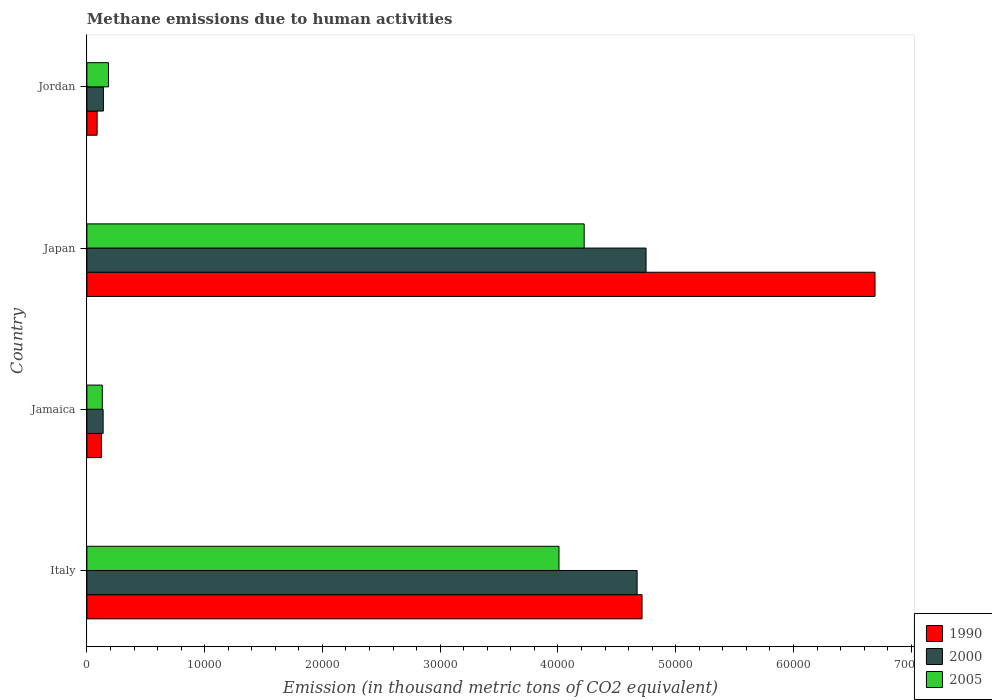How many different coloured bars are there?
Make the answer very short. 3. Are the number of bars on each tick of the Y-axis equal?
Ensure brevity in your answer.  Yes. How many bars are there on the 2nd tick from the top?
Your answer should be compact. 3. How many bars are there on the 4th tick from the bottom?
Your answer should be compact. 3. What is the label of the 1st group of bars from the top?
Offer a very short reply. Jordan. What is the amount of methane emitted in 2005 in Japan?
Your response must be concise. 4.22e+04. Across all countries, what is the maximum amount of methane emitted in 2000?
Keep it short and to the point. 4.75e+04. Across all countries, what is the minimum amount of methane emitted in 2000?
Ensure brevity in your answer.  1379.2. In which country was the amount of methane emitted in 2000 maximum?
Offer a very short reply. Japan. In which country was the amount of methane emitted in 2005 minimum?
Make the answer very short. Jamaica. What is the total amount of methane emitted in 2000 in the graph?
Give a very brief answer. 9.70e+04. What is the difference between the amount of methane emitted in 2005 in Japan and that in Jordan?
Give a very brief answer. 4.04e+04. What is the difference between the amount of methane emitted in 2005 in Italy and the amount of methane emitted in 1990 in Jordan?
Ensure brevity in your answer.  3.92e+04. What is the average amount of methane emitted in 1990 per country?
Make the answer very short. 2.90e+04. What is the difference between the amount of methane emitted in 2005 and amount of methane emitted in 1990 in Jamaica?
Your answer should be very brief. 71.4. In how many countries, is the amount of methane emitted in 2005 greater than 68000 thousand metric tons?
Offer a terse response. 0. What is the ratio of the amount of methane emitted in 1990 in Japan to that in Jordan?
Make the answer very short. 77.19. Is the amount of methane emitted in 2000 in Jamaica less than that in Jordan?
Your response must be concise. Yes. What is the difference between the highest and the second highest amount of methane emitted in 2000?
Give a very brief answer. 758.6. What is the difference between the highest and the lowest amount of methane emitted in 1990?
Ensure brevity in your answer.  6.61e+04. Is it the case that in every country, the sum of the amount of methane emitted in 2000 and amount of methane emitted in 2005 is greater than the amount of methane emitted in 1990?
Offer a very short reply. Yes. Are all the bars in the graph horizontal?
Ensure brevity in your answer.  Yes. How many countries are there in the graph?
Keep it short and to the point. 4. What is the difference between two consecutive major ticks on the X-axis?
Your answer should be compact. 10000. Does the graph contain grids?
Provide a short and direct response. No. How many legend labels are there?
Offer a terse response. 3. What is the title of the graph?
Your response must be concise. Methane emissions due to human activities. What is the label or title of the X-axis?
Your response must be concise. Emission (in thousand metric tons of CO2 equivalent). What is the label or title of the Y-axis?
Offer a very short reply. Country. What is the Emission (in thousand metric tons of CO2 equivalent) of 1990 in Italy?
Your answer should be compact. 4.71e+04. What is the Emission (in thousand metric tons of CO2 equivalent) in 2000 in Italy?
Offer a very short reply. 4.67e+04. What is the Emission (in thousand metric tons of CO2 equivalent) of 2005 in Italy?
Keep it short and to the point. 4.01e+04. What is the Emission (in thousand metric tons of CO2 equivalent) of 1990 in Jamaica?
Your answer should be very brief. 1235.1. What is the Emission (in thousand metric tons of CO2 equivalent) of 2000 in Jamaica?
Provide a succinct answer. 1379.2. What is the Emission (in thousand metric tons of CO2 equivalent) in 2005 in Jamaica?
Keep it short and to the point. 1306.5. What is the Emission (in thousand metric tons of CO2 equivalent) in 1990 in Japan?
Your answer should be compact. 6.69e+04. What is the Emission (in thousand metric tons of CO2 equivalent) of 2000 in Japan?
Make the answer very short. 4.75e+04. What is the Emission (in thousand metric tons of CO2 equivalent) in 2005 in Japan?
Make the answer very short. 4.22e+04. What is the Emission (in thousand metric tons of CO2 equivalent) in 1990 in Jordan?
Your answer should be very brief. 867.1. What is the Emission (in thousand metric tons of CO2 equivalent) of 2000 in Jordan?
Make the answer very short. 1401.8. What is the Emission (in thousand metric tons of CO2 equivalent) of 2005 in Jordan?
Your response must be concise. 1833.2. Across all countries, what is the maximum Emission (in thousand metric tons of CO2 equivalent) of 1990?
Provide a succinct answer. 6.69e+04. Across all countries, what is the maximum Emission (in thousand metric tons of CO2 equivalent) of 2000?
Provide a succinct answer. 4.75e+04. Across all countries, what is the maximum Emission (in thousand metric tons of CO2 equivalent) in 2005?
Offer a terse response. 4.22e+04. Across all countries, what is the minimum Emission (in thousand metric tons of CO2 equivalent) of 1990?
Offer a very short reply. 867.1. Across all countries, what is the minimum Emission (in thousand metric tons of CO2 equivalent) in 2000?
Offer a very short reply. 1379.2. Across all countries, what is the minimum Emission (in thousand metric tons of CO2 equivalent) of 2005?
Ensure brevity in your answer.  1306.5. What is the total Emission (in thousand metric tons of CO2 equivalent) of 1990 in the graph?
Your answer should be compact. 1.16e+05. What is the total Emission (in thousand metric tons of CO2 equivalent) in 2000 in the graph?
Provide a short and direct response. 9.70e+04. What is the total Emission (in thousand metric tons of CO2 equivalent) in 2005 in the graph?
Provide a short and direct response. 8.55e+04. What is the difference between the Emission (in thousand metric tons of CO2 equivalent) in 1990 in Italy and that in Jamaica?
Your answer should be compact. 4.59e+04. What is the difference between the Emission (in thousand metric tons of CO2 equivalent) of 2000 in Italy and that in Jamaica?
Provide a succinct answer. 4.53e+04. What is the difference between the Emission (in thousand metric tons of CO2 equivalent) of 2005 in Italy and that in Jamaica?
Give a very brief answer. 3.88e+04. What is the difference between the Emission (in thousand metric tons of CO2 equivalent) of 1990 in Italy and that in Japan?
Provide a succinct answer. -1.98e+04. What is the difference between the Emission (in thousand metric tons of CO2 equivalent) of 2000 in Italy and that in Japan?
Keep it short and to the point. -758.6. What is the difference between the Emission (in thousand metric tons of CO2 equivalent) of 2005 in Italy and that in Japan?
Provide a short and direct response. -2140.2. What is the difference between the Emission (in thousand metric tons of CO2 equivalent) in 1990 in Italy and that in Jordan?
Provide a succinct answer. 4.63e+04. What is the difference between the Emission (in thousand metric tons of CO2 equivalent) in 2000 in Italy and that in Jordan?
Your response must be concise. 4.53e+04. What is the difference between the Emission (in thousand metric tons of CO2 equivalent) of 2005 in Italy and that in Jordan?
Make the answer very short. 3.83e+04. What is the difference between the Emission (in thousand metric tons of CO2 equivalent) in 1990 in Jamaica and that in Japan?
Your answer should be compact. -6.57e+04. What is the difference between the Emission (in thousand metric tons of CO2 equivalent) in 2000 in Jamaica and that in Japan?
Ensure brevity in your answer.  -4.61e+04. What is the difference between the Emission (in thousand metric tons of CO2 equivalent) of 2005 in Jamaica and that in Japan?
Provide a short and direct response. -4.09e+04. What is the difference between the Emission (in thousand metric tons of CO2 equivalent) of 1990 in Jamaica and that in Jordan?
Keep it short and to the point. 368. What is the difference between the Emission (in thousand metric tons of CO2 equivalent) in 2000 in Jamaica and that in Jordan?
Keep it short and to the point. -22.6. What is the difference between the Emission (in thousand metric tons of CO2 equivalent) in 2005 in Jamaica and that in Jordan?
Make the answer very short. -526.7. What is the difference between the Emission (in thousand metric tons of CO2 equivalent) of 1990 in Japan and that in Jordan?
Provide a succinct answer. 6.61e+04. What is the difference between the Emission (in thousand metric tons of CO2 equivalent) of 2000 in Japan and that in Jordan?
Your answer should be very brief. 4.61e+04. What is the difference between the Emission (in thousand metric tons of CO2 equivalent) of 2005 in Japan and that in Jordan?
Ensure brevity in your answer.  4.04e+04. What is the difference between the Emission (in thousand metric tons of CO2 equivalent) in 1990 in Italy and the Emission (in thousand metric tons of CO2 equivalent) in 2000 in Jamaica?
Provide a short and direct response. 4.58e+04. What is the difference between the Emission (in thousand metric tons of CO2 equivalent) in 1990 in Italy and the Emission (in thousand metric tons of CO2 equivalent) in 2005 in Jamaica?
Your response must be concise. 4.58e+04. What is the difference between the Emission (in thousand metric tons of CO2 equivalent) in 2000 in Italy and the Emission (in thousand metric tons of CO2 equivalent) in 2005 in Jamaica?
Keep it short and to the point. 4.54e+04. What is the difference between the Emission (in thousand metric tons of CO2 equivalent) in 1990 in Italy and the Emission (in thousand metric tons of CO2 equivalent) in 2000 in Japan?
Give a very brief answer. -339.7. What is the difference between the Emission (in thousand metric tons of CO2 equivalent) of 1990 in Italy and the Emission (in thousand metric tons of CO2 equivalent) of 2005 in Japan?
Ensure brevity in your answer.  4914.3. What is the difference between the Emission (in thousand metric tons of CO2 equivalent) of 2000 in Italy and the Emission (in thousand metric tons of CO2 equivalent) of 2005 in Japan?
Your answer should be compact. 4495.4. What is the difference between the Emission (in thousand metric tons of CO2 equivalent) in 1990 in Italy and the Emission (in thousand metric tons of CO2 equivalent) in 2000 in Jordan?
Your answer should be very brief. 4.57e+04. What is the difference between the Emission (in thousand metric tons of CO2 equivalent) in 1990 in Italy and the Emission (in thousand metric tons of CO2 equivalent) in 2005 in Jordan?
Offer a very short reply. 4.53e+04. What is the difference between the Emission (in thousand metric tons of CO2 equivalent) of 2000 in Italy and the Emission (in thousand metric tons of CO2 equivalent) of 2005 in Jordan?
Your answer should be compact. 4.49e+04. What is the difference between the Emission (in thousand metric tons of CO2 equivalent) of 1990 in Jamaica and the Emission (in thousand metric tons of CO2 equivalent) of 2000 in Japan?
Your response must be concise. -4.62e+04. What is the difference between the Emission (in thousand metric tons of CO2 equivalent) in 1990 in Jamaica and the Emission (in thousand metric tons of CO2 equivalent) in 2005 in Japan?
Provide a succinct answer. -4.10e+04. What is the difference between the Emission (in thousand metric tons of CO2 equivalent) of 2000 in Jamaica and the Emission (in thousand metric tons of CO2 equivalent) of 2005 in Japan?
Provide a succinct answer. -4.09e+04. What is the difference between the Emission (in thousand metric tons of CO2 equivalent) of 1990 in Jamaica and the Emission (in thousand metric tons of CO2 equivalent) of 2000 in Jordan?
Provide a short and direct response. -166.7. What is the difference between the Emission (in thousand metric tons of CO2 equivalent) in 1990 in Jamaica and the Emission (in thousand metric tons of CO2 equivalent) in 2005 in Jordan?
Provide a succinct answer. -598.1. What is the difference between the Emission (in thousand metric tons of CO2 equivalent) in 2000 in Jamaica and the Emission (in thousand metric tons of CO2 equivalent) in 2005 in Jordan?
Your response must be concise. -454. What is the difference between the Emission (in thousand metric tons of CO2 equivalent) of 1990 in Japan and the Emission (in thousand metric tons of CO2 equivalent) of 2000 in Jordan?
Your answer should be very brief. 6.55e+04. What is the difference between the Emission (in thousand metric tons of CO2 equivalent) of 1990 in Japan and the Emission (in thousand metric tons of CO2 equivalent) of 2005 in Jordan?
Ensure brevity in your answer.  6.51e+04. What is the difference between the Emission (in thousand metric tons of CO2 equivalent) of 2000 in Japan and the Emission (in thousand metric tons of CO2 equivalent) of 2005 in Jordan?
Keep it short and to the point. 4.57e+04. What is the average Emission (in thousand metric tons of CO2 equivalent) in 1990 per country?
Ensure brevity in your answer.  2.90e+04. What is the average Emission (in thousand metric tons of CO2 equivalent) in 2000 per country?
Your answer should be compact. 2.42e+04. What is the average Emission (in thousand metric tons of CO2 equivalent) of 2005 per country?
Your answer should be very brief. 2.14e+04. What is the difference between the Emission (in thousand metric tons of CO2 equivalent) in 1990 and Emission (in thousand metric tons of CO2 equivalent) in 2000 in Italy?
Keep it short and to the point. 418.9. What is the difference between the Emission (in thousand metric tons of CO2 equivalent) of 1990 and Emission (in thousand metric tons of CO2 equivalent) of 2005 in Italy?
Keep it short and to the point. 7054.5. What is the difference between the Emission (in thousand metric tons of CO2 equivalent) in 2000 and Emission (in thousand metric tons of CO2 equivalent) in 2005 in Italy?
Make the answer very short. 6635.6. What is the difference between the Emission (in thousand metric tons of CO2 equivalent) in 1990 and Emission (in thousand metric tons of CO2 equivalent) in 2000 in Jamaica?
Offer a terse response. -144.1. What is the difference between the Emission (in thousand metric tons of CO2 equivalent) in 1990 and Emission (in thousand metric tons of CO2 equivalent) in 2005 in Jamaica?
Provide a succinct answer. -71.4. What is the difference between the Emission (in thousand metric tons of CO2 equivalent) of 2000 and Emission (in thousand metric tons of CO2 equivalent) of 2005 in Jamaica?
Offer a very short reply. 72.7. What is the difference between the Emission (in thousand metric tons of CO2 equivalent) of 1990 and Emission (in thousand metric tons of CO2 equivalent) of 2000 in Japan?
Provide a succinct answer. 1.94e+04. What is the difference between the Emission (in thousand metric tons of CO2 equivalent) of 1990 and Emission (in thousand metric tons of CO2 equivalent) of 2005 in Japan?
Your response must be concise. 2.47e+04. What is the difference between the Emission (in thousand metric tons of CO2 equivalent) of 2000 and Emission (in thousand metric tons of CO2 equivalent) of 2005 in Japan?
Ensure brevity in your answer.  5254. What is the difference between the Emission (in thousand metric tons of CO2 equivalent) of 1990 and Emission (in thousand metric tons of CO2 equivalent) of 2000 in Jordan?
Provide a short and direct response. -534.7. What is the difference between the Emission (in thousand metric tons of CO2 equivalent) of 1990 and Emission (in thousand metric tons of CO2 equivalent) of 2005 in Jordan?
Keep it short and to the point. -966.1. What is the difference between the Emission (in thousand metric tons of CO2 equivalent) of 2000 and Emission (in thousand metric tons of CO2 equivalent) of 2005 in Jordan?
Your answer should be compact. -431.4. What is the ratio of the Emission (in thousand metric tons of CO2 equivalent) in 1990 in Italy to that in Jamaica?
Ensure brevity in your answer.  38.17. What is the ratio of the Emission (in thousand metric tons of CO2 equivalent) of 2000 in Italy to that in Jamaica?
Provide a succinct answer. 33.88. What is the ratio of the Emission (in thousand metric tons of CO2 equivalent) of 2005 in Italy to that in Jamaica?
Offer a terse response. 30.68. What is the ratio of the Emission (in thousand metric tons of CO2 equivalent) in 1990 in Italy to that in Japan?
Your response must be concise. 0.7. What is the ratio of the Emission (in thousand metric tons of CO2 equivalent) of 2005 in Italy to that in Japan?
Offer a very short reply. 0.95. What is the ratio of the Emission (in thousand metric tons of CO2 equivalent) in 1990 in Italy to that in Jordan?
Your answer should be very brief. 54.37. What is the ratio of the Emission (in thousand metric tons of CO2 equivalent) of 2000 in Italy to that in Jordan?
Make the answer very short. 33.33. What is the ratio of the Emission (in thousand metric tons of CO2 equivalent) in 2005 in Italy to that in Jordan?
Your answer should be very brief. 21.87. What is the ratio of the Emission (in thousand metric tons of CO2 equivalent) in 1990 in Jamaica to that in Japan?
Your answer should be very brief. 0.02. What is the ratio of the Emission (in thousand metric tons of CO2 equivalent) of 2000 in Jamaica to that in Japan?
Your response must be concise. 0.03. What is the ratio of the Emission (in thousand metric tons of CO2 equivalent) of 2005 in Jamaica to that in Japan?
Provide a short and direct response. 0.03. What is the ratio of the Emission (in thousand metric tons of CO2 equivalent) of 1990 in Jamaica to that in Jordan?
Provide a short and direct response. 1.42. What is the ratio of the Emission (in thousand metric tons of CO2 equivalent) in 2000 in Jamaica to that in Jordan?
Ensure brevity in your answer.  0.98. What is the ratio of the Emission (in thousand metric tons of CO2 equivalent) in 2005 in Jamaica to that in Jordan?
Your answer should be compact. 0.71. What is the ratio of the Emission (in thousand metric tons of CO2 equivalent) of 1990 in Japan to that in Jordan?
Offer a very short reply. 77.19. What is the ratio of the Emission (in thousand metric tons of CO2 equivalent) of 2000 in Japan to that in Jordan?
Your response must be concise. 33.87. What is the ratio of the Emission (in thousand metric tons of CO2 equivalent) in 2005 in Japan to that in Jordan?
Your answer should be compact. 23.04. What is the difference between the highest and the second highest Emission (in thousand metric tons of CO2 equivalent) of 1990?
Make the answer very short. 1.98e+04. What is the difference between the highest and the second highest Emission (in thousand metric tons of CO2 equivalent) in 2000?
Make the answer very short. 758.6. What is the difference between the highest and the second highest Emission (in thousand metric tons of CO2 equivalent) in 2005?
Offer a terse response. 2140.2. What is the difference between the highest and the lowest Emission (in thousand metric tons of CO2 equivalent) of 1990?
Provide a short and direct response. 6.61e+04. What is the difference between the highest and the lowest Emission (in thousand metric tons of CO2 equivalent) of 2000?
Provide a succinct answer. 4.61e+04. What is the difference between the highest and the lowest Emission (in thousand metric tons of CO2 equivalent) in 2005?
Your answer should be very brief. 4.09e+04. 